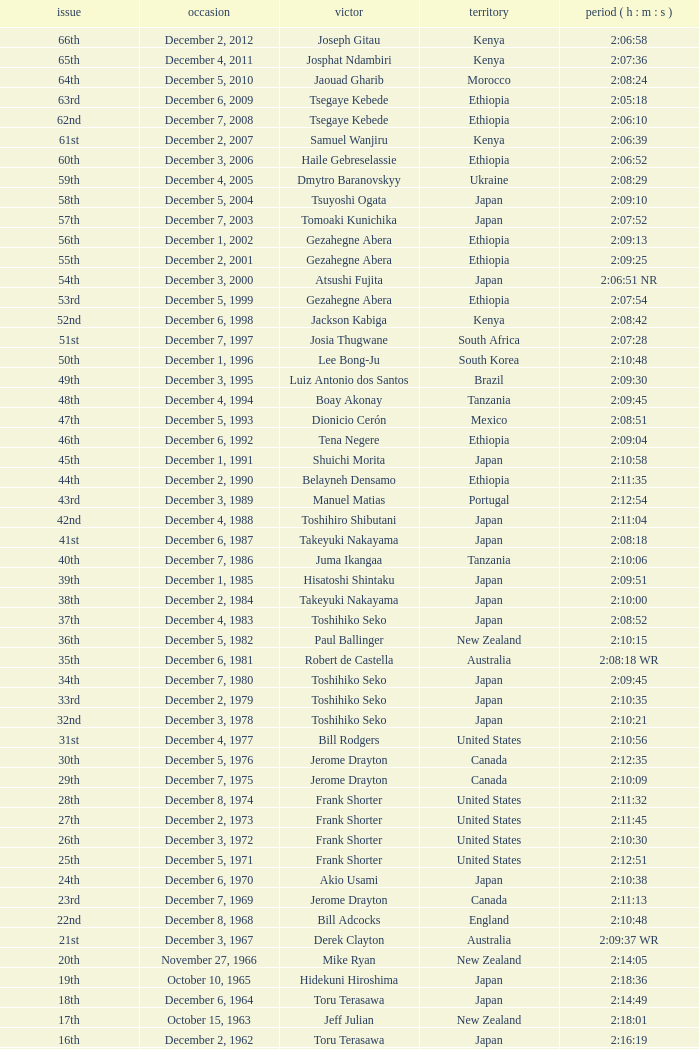What was the nationality of the winner for the 20th Edition? New Zealand. 